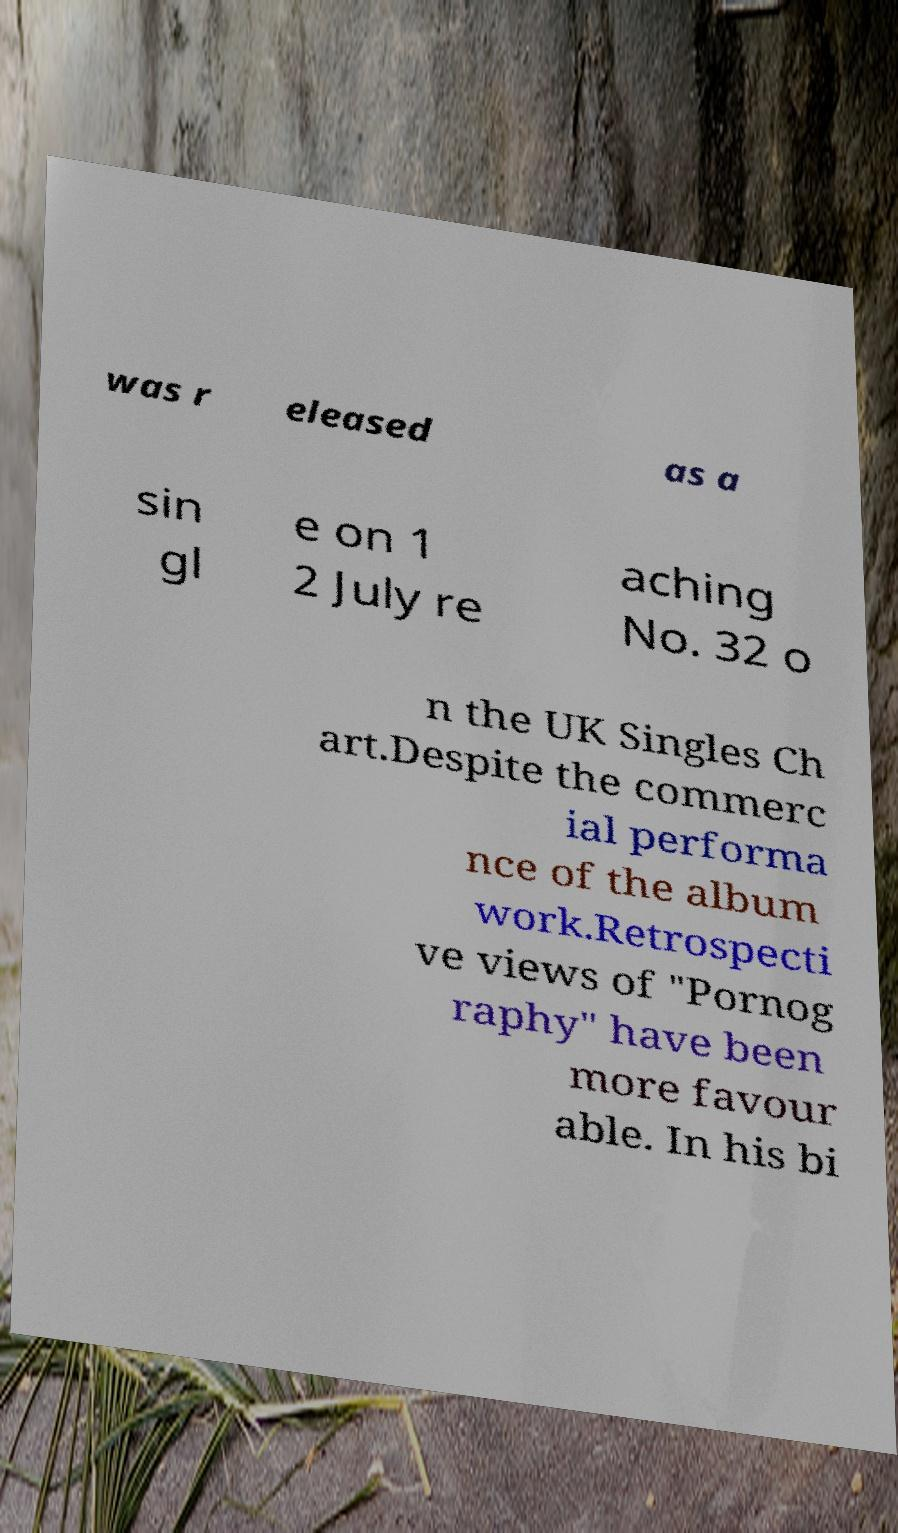For documentation purposes, I need the text within this image transcribed. Could you provide that? was r eleased as a sin gl e on 1 2 July re aching No. 32 o n the UK Singles Ch art.Despite the commerc ial performa nce of the album work.Retrospecti ve views of "Pornog raphy" have been more favour able. In his bi 